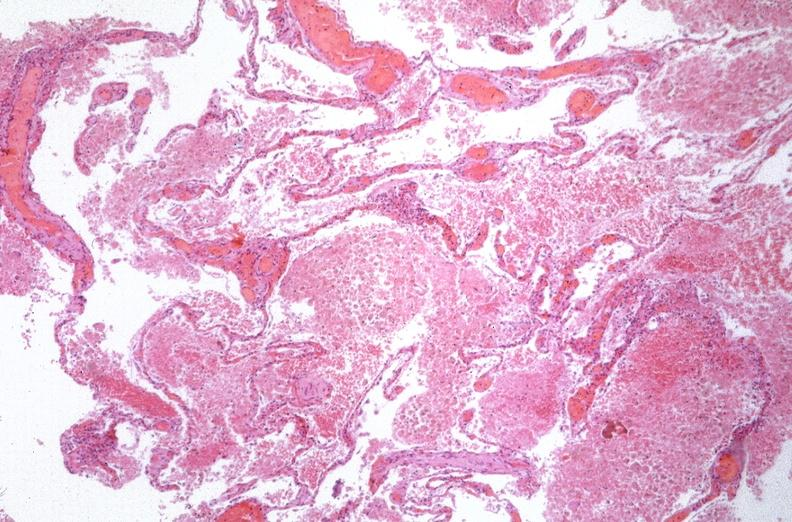where is this?
Answer the question using a single word or phrase. Lung 